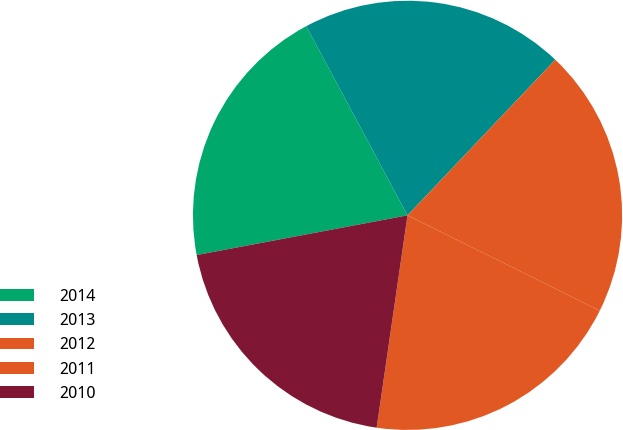Convert chart to OTSL. <chart><loc_0><loc_0><loc_500><loc_500><pie_chart><fcel>2014<fcel>2013<fcel>2012<fcel>2011<fcel>2010<nl><fcel>20.14%<fcel>19.91%<fcel>20.24%<fcel>19.97%<fcel>19.74%<nl></chart> 